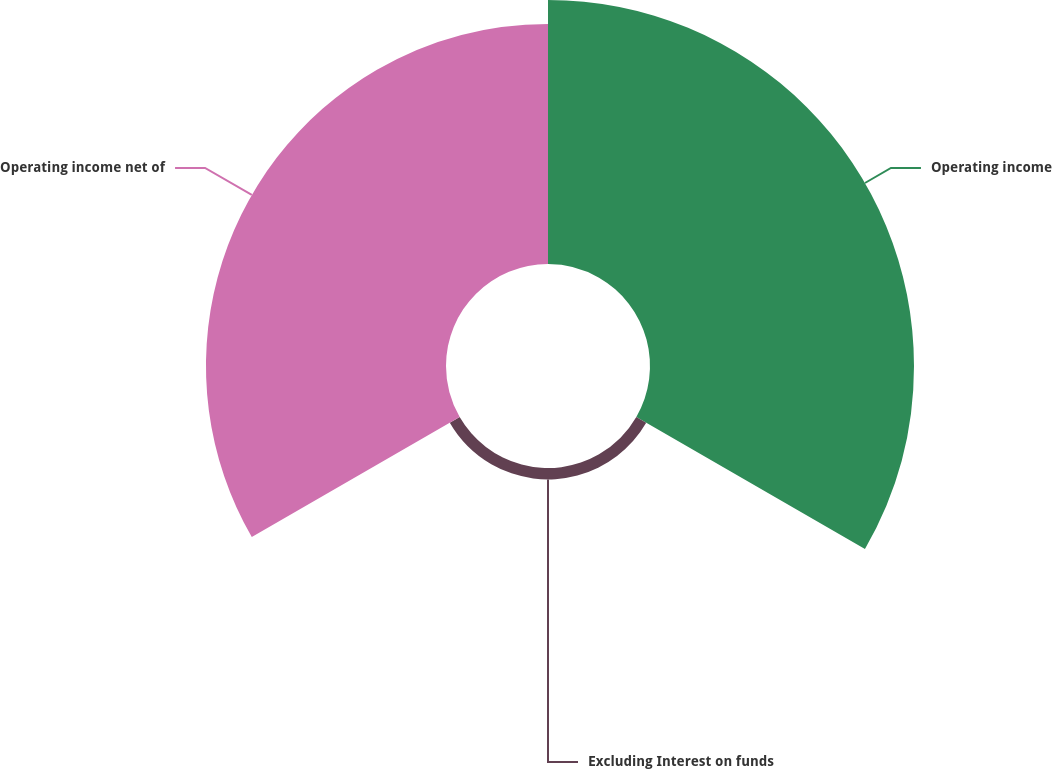Convert chart. <chart><loc_0><loc_0><loc_500><loc_500><pie_chart><fcel>Operating income<fcel>Excluding Interest on funds<fcel>Operating income net of<nl><fcel>51.22%<fcel>2.21%<fcel>46.57%<nl></chart> 